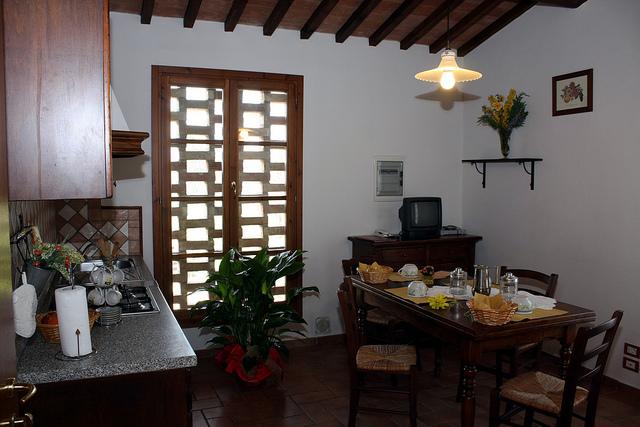Is that an old lamp?
Give a very brief answer. No. Is the light on?
Keep it brief. Yes. Are the dishes on the table dirty?
Be succinct. No. How many plants are in the room?
Give a very brief answer. 2. What color flowers are in the vase to the left?
Concise answer only. Yellow. 